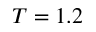Convert formula to latex. <formula><loc_0><loc_0><loc_500><loc_500>T = 1 . 2</formula> 